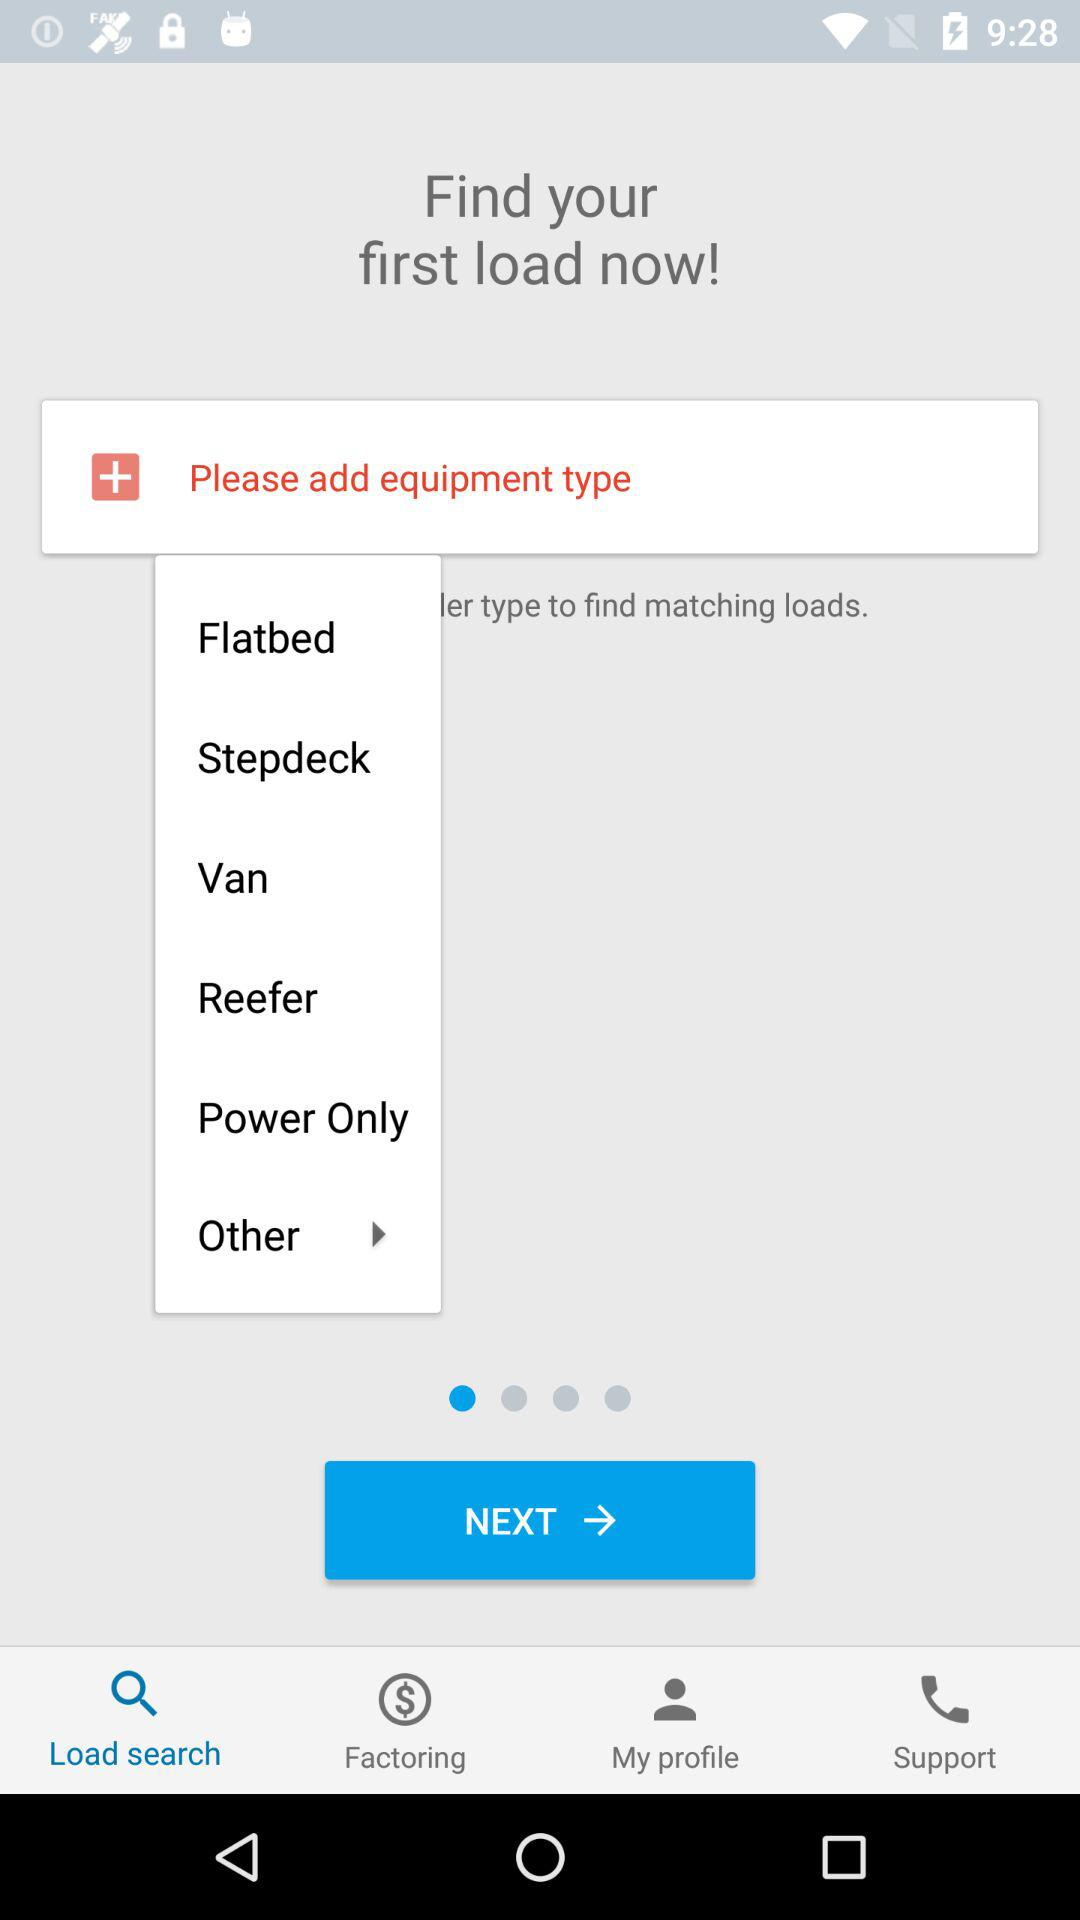How many types of equipment are there?
Answer the question using a single word or phrase. 6 